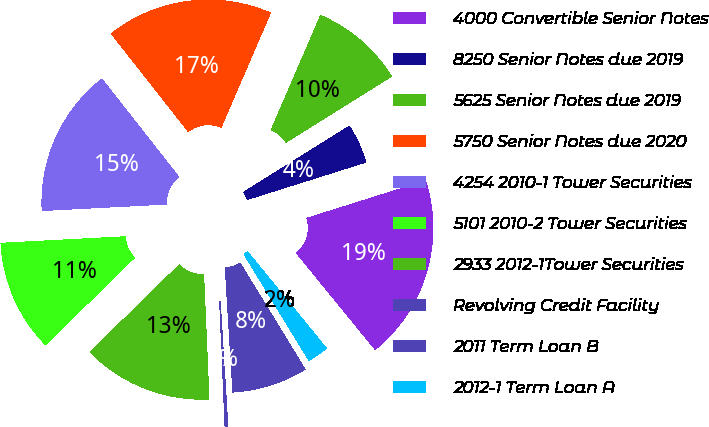Convert chart. <chart><loc_0><loc_0><loc_500><loc_500><pie_chart><fcel>4000 Convertible Senior Notes<fcel>8250 Senior Notes due 2019<fcel>5625 Senior Notes due 2019<fcel>5750 Senior Notes due 2020<fcel>4254 2010-1 Tower Securities<fcel>5101 2010-2 Tower Securities<fcel>2933 2012-1Tower Securities<fcel>Revolving Credit Facility<fcel>2011 Term Loan B<fcel>2012-1 Term Loan A<nl><fcel>18.96%<fcel>4.03%<fcel>9.63%<fcel>17.09%<fcel>15.23%<fcel>11.49%<fcel>13.36%<fcel>0.29%<fcel>7.76%<fcel>2.16%<nl></chart> 